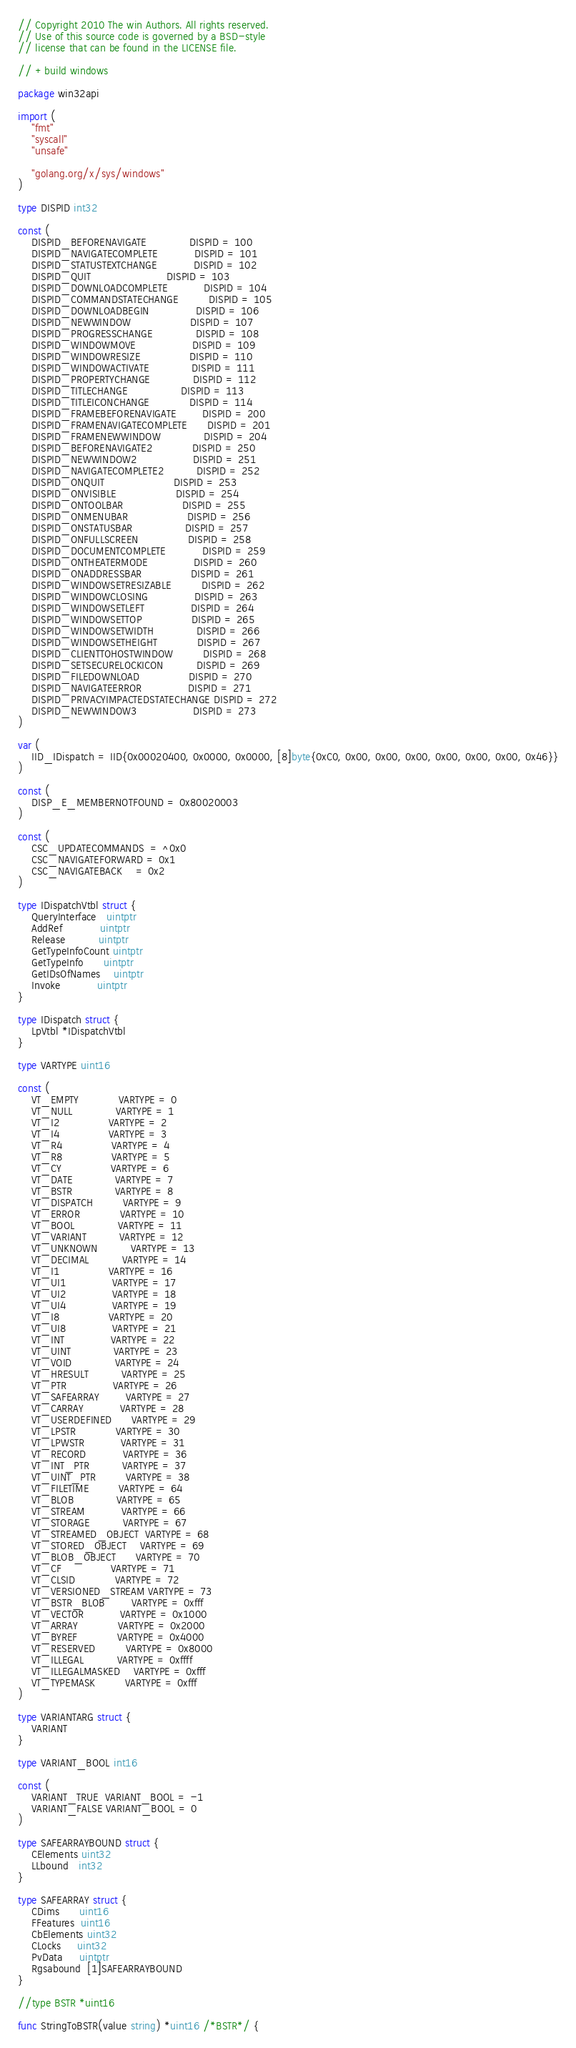<code> <loc_0><loc_0><loc_500><loc_500><_Go_>// Copyright 2010 The win Authors. All rights reserved.
// Use of this source code is governed by a BSD-style
// license that can be found in the LICENSE file.

// +build windows

package win32api

import (
	"fmt"
	"syscall"
	"unsafe"

	"golang.org/x/sys/windows"
)

type DISPID int32

const (
	DISPID_BEFORENAVIGATE             DISPID = 100
	DISPID_NAVIGATECOMPLETE           DISPID = 101
	DISPID_STATUSTEXTCHANGE           DISPID = 102
	DISPID_QUIT                       DISPID = 103
	DISPID_DOWNLOADCOMPLETE           DISPID = 104
	DISPID_COMMANDSTATECHANGE         DISPID = 105
	DISPID_DOWNLOADBEGIN              DISPID = 106
	DISPID_NEWWINDOW                  DISPID = 107
	DISPID_PROGRESSCHANGE             DISPID = 108
	DISPID_WINDOWMOVE                 DISPID = 109
	DISPID_WINDOWRESIZE               DISPID = 110
	DISPID_WINDOWACTIVATE             DISPID = 111
	DISPID_PROPERTYCHANGE             DISPID = 112
	DISPID_TITLECHANGE                DISPID = 113
	DISPID_TITLEICONCHANGE            DISPID = 114
	DISPID_FRAMEBEFORENAVIGATE        DISPID = 200
	DISPID_FRAMENAVIGATECOMPLETE      DISPID = 201
	DISPID_FRAMENEWWINDOW             DISPID = 204
	DISPID_BEFORENAVIGATE2            DISPID = 250
	DISPID_NEWWINDOW2                 DISPID = 251
	DISPID_NAVIGATECOMPLETE2          DISPID = 252
	DISPID_ONQUIT                     DISPID = 253
	DISPID_ONVISIBLE                  DISPID = 254
	DISPID_ONTOOLBAR                  DISPID = 255
	DISPID_ONMENUBAR                  DISPID = 256
	DISPID_ONSTATUSBAR                DISPID = 257
	DISPID_ONFULLSCREEN               DISPID = 258
	DISPID_DOCUMENTCOMPLETE           DISPID = 259
	DISPID_ONTHEATERMODE              DISPID = 260
	DISPID_ONADDRESSBAR               DISPID = 261
	DISPID_WINDOWSETRESIZABLE         DISPID = 262
	DISPID_WINDOWCLOSING              DISPID = 263
	DISPID_WINDOWSETLEFT              DISPID = 264
	DISPID_WINDOWSETTOP               DISPID = 265
	DISPID_WINDOWSETWIDTH             DISPID = 266
	DISPID_WINDOWSETHEIGHT            DISPID = 267
	DISPID_CLIENTTOHOSTWINDOW         DISPID = 268
	DISPID_SETSECURELOCKICON          DISPID = 269
	DISPID_FILEDOWNLOAD               DISPID = 270
	DISPID_NAVIGATEERROR              DISPID = 271
	DISPID_PRIVACYIMPACTEDSTATECHANGE DISPID = 272
	DISPID_NEWWINDOW3                 DISPID = 273
)

var (
	IID_IDispatch = IID{0x00020400, 0x0000, 0x0000, [8]byte{0xC0, 0x00, 0x00, 0x00, 0x00, 0x00, 0x00, 0x46}}
)

const (
	DISP_E_MEMBERNOTFOUND = 0x80020003
)

const (
	CSC_UPDATECOMMANDS  = ^0x0
	CSC_NAVIGATEFORWARD = 0x1
	CSC_NAVIGATEBACK    = 0x2
)

type IDispatchVtbl struct {
	QueryInterface   uintptr
	AddRef           uintptr
	Release          uintptr
	GetTypeInfoCount uintptr
	GetTypeInfo      uintptr
	GetIDsOfNames    uintptr
	Invoke           uintptr
}

type IDispatch struct {
	LpVtbl *IDispatchVtbl
}

type VARTYPE uint16

const (
	VT_EMPTY            VARTYPE = 0
	VT_NULL             VARTYPE = 1
	VT_I2               VARTYPE = 2
	VT_I4               VARTYPE = 3
	VT_R4               VARTYPE = 4
	VT_R8               VARTYPE = 5
	VT_CY               VARTYPE = 6
	VT_DATE             VARTYPE = 7
	VT_BSTR             VARTYPE = 8
	VT_DISPATCH         VARTYPE = 9
	VT_ERROR            VARTYPE = 10
	VT_BOOL             VARTYPE = 11
	VT_VARIANT          VARTYPE = 12
	VT_UNKNOWN          VARTYPE = 13
	VT_DECIMAL          VARTYPE = 14
	VT_I1               VARTYPE = 16
	VT_UI1              VARTYPE = 17
	VT_UI2              VARTYPE = 18
	VT_UI4              VARTYPE = 19
	VT_I8               VARTYPE = 20
	VT_UI8              VARTYPE = 21
	VT_INT              VARTYPE = 22
	VT_UINT             VARTYPE = 23
	VT_VOID             VARTYPE = 24
	VT_HRESULT          VARTYPE = 25
	VT_PTR              VARTYPE = 26
	VT_SAFEARRAY        VARTYPE = 27
	VT_CARRAY           VARTYPE = 28
	VT_USERDEFINED      VARTYPE = 29
	VT_LPSTR            VARTYPE = 30
	VT_LPWSTR           VARTYPE = 31
	VT_RECORD           VARTYPE = 36
	VT_INT_PTR          VARTYPE = 37
	VT_UINT_PTR         VARTYPE = 38
	VT_FILETIME         VARTYPE = 64
	VT_BLOB             VARTYPE = 65
	VT_STREAM           VARTYPE = 66
	VT_STORAGE          VARTYPE = 67
	VT_STREAMED_OBJECT  VARTYPE = 68
	VT_STORED_OBJECT    VARTYPE = 69
	VT_BLOB_OBJECT      VARTYPE = 70
	VT_CF               VARTYPE = 71
	VT_CLSID            VARTYPE = 72
	VT_VERSIONED_STREAM VARTYPE = 73
	VT_BSTR_BLOB        VARTYPE = 0xfff
	VT_VECTOR           VARTYPE = 0x1000
	VT_ARRAY            VARTYPE = 0x2000
	VT_BYREF            VARTYPE = 0x4000
	VT_RESERVED         VARTYPE = 0x8000
	VT_ILLEGAL          VARTYPE = 0xffff
	VT_ILLEGALMASKED    VARTYPE = 0xfff
	VT_TYPEMASK         VARTYPE = 0xfff
)

type VARIANTARG struct {
	VARIANT
}

type VARIANT_BOOL int16

const (
	VARIANT_TRUE  VARIANT_BOOL = -1
	VARIANT_FALSE VARIANT_BOOL = 0
)

type SAFEARRAYBOUND struct {
	CElements uint32
	LLbound   int32
}

type SAFEARRAY struct {
	CDims      uint16
	FFeatures  uint16
	CbElements uint32
	CLocks     uint32
	PvData     uintptr
	Rgsabound  [1]SAFEARRAYBOUND
}

//type BSTR *uint16

func StringToBSTR(value string) *uint16 /*BSTR*/ {</code> 